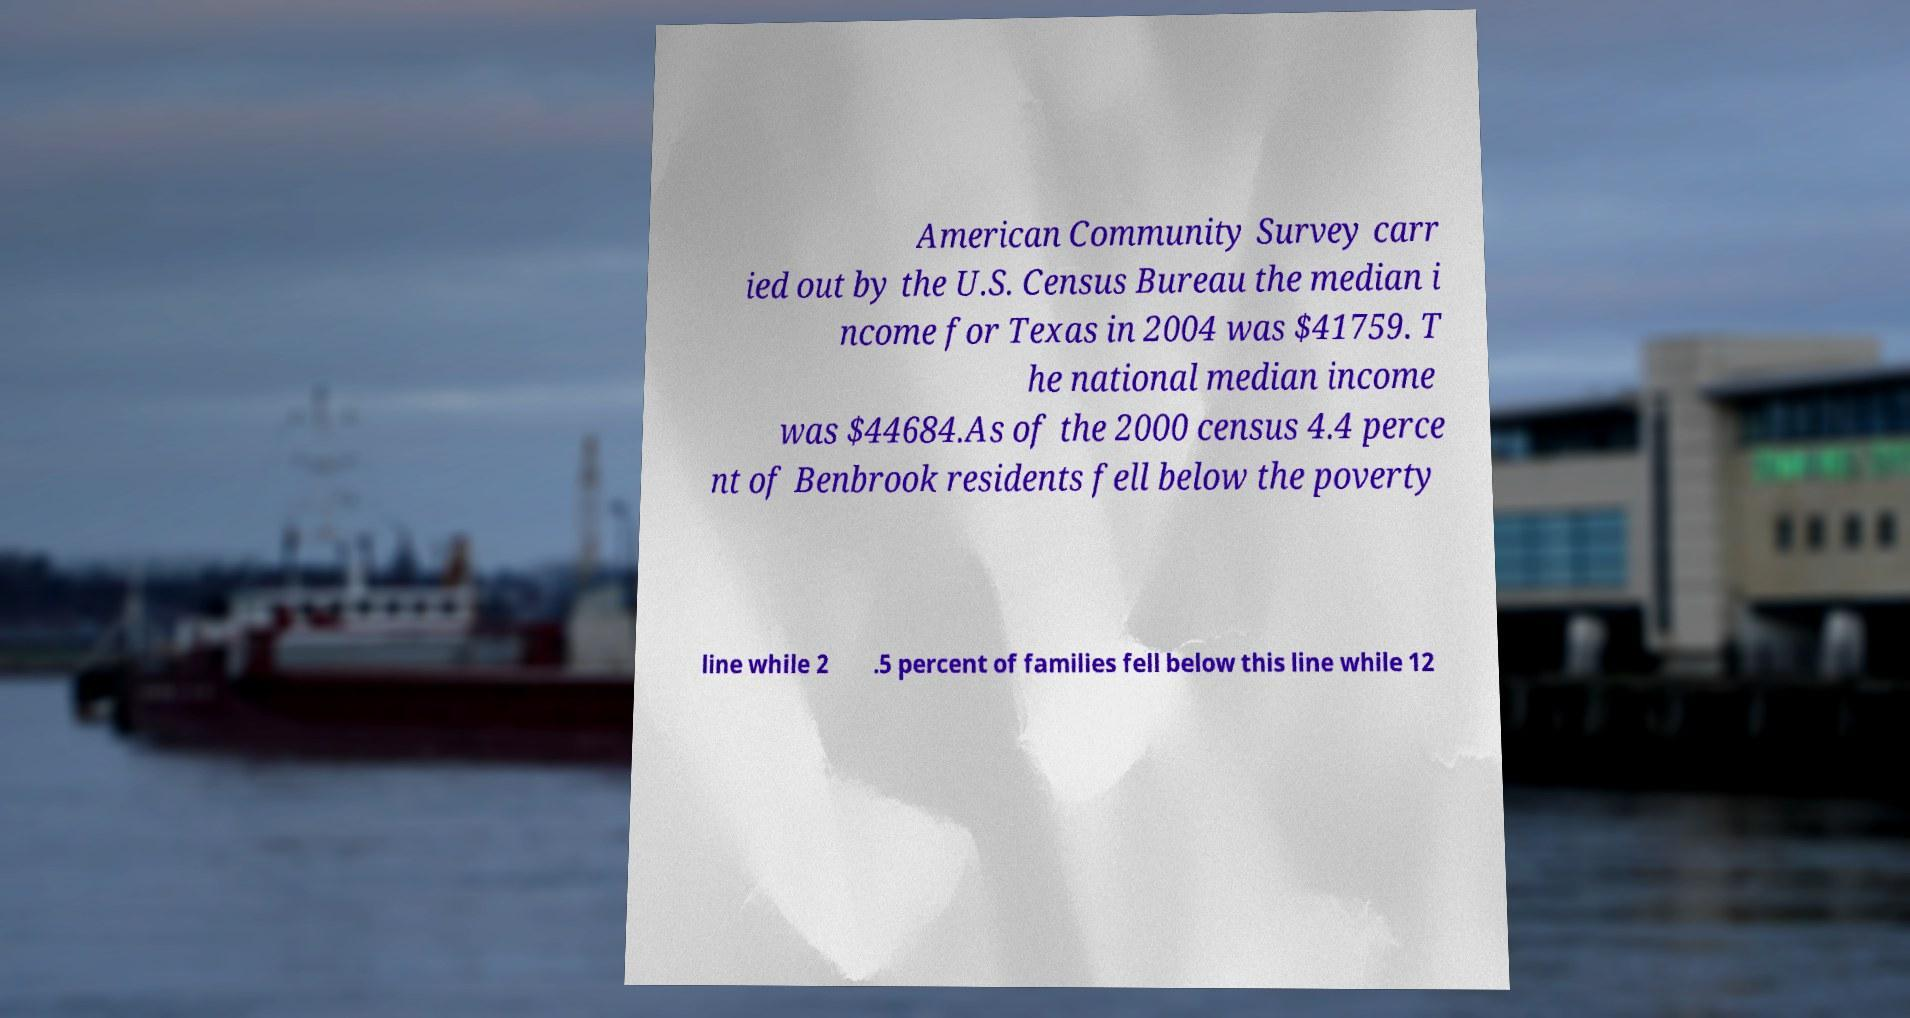There's text embedded in this image that I need extracted. Can you transcribe it verbatim? American Community Survey carr ied out by the U.S. Census Bureau the median i ncome for Texas in 2004 was $41759. T he national median income was $44684.As of the 2000 census 4.4 perce nt of Benbrook residents fell below the poverty line while 2 .5 percent of families fell below this line while 12 